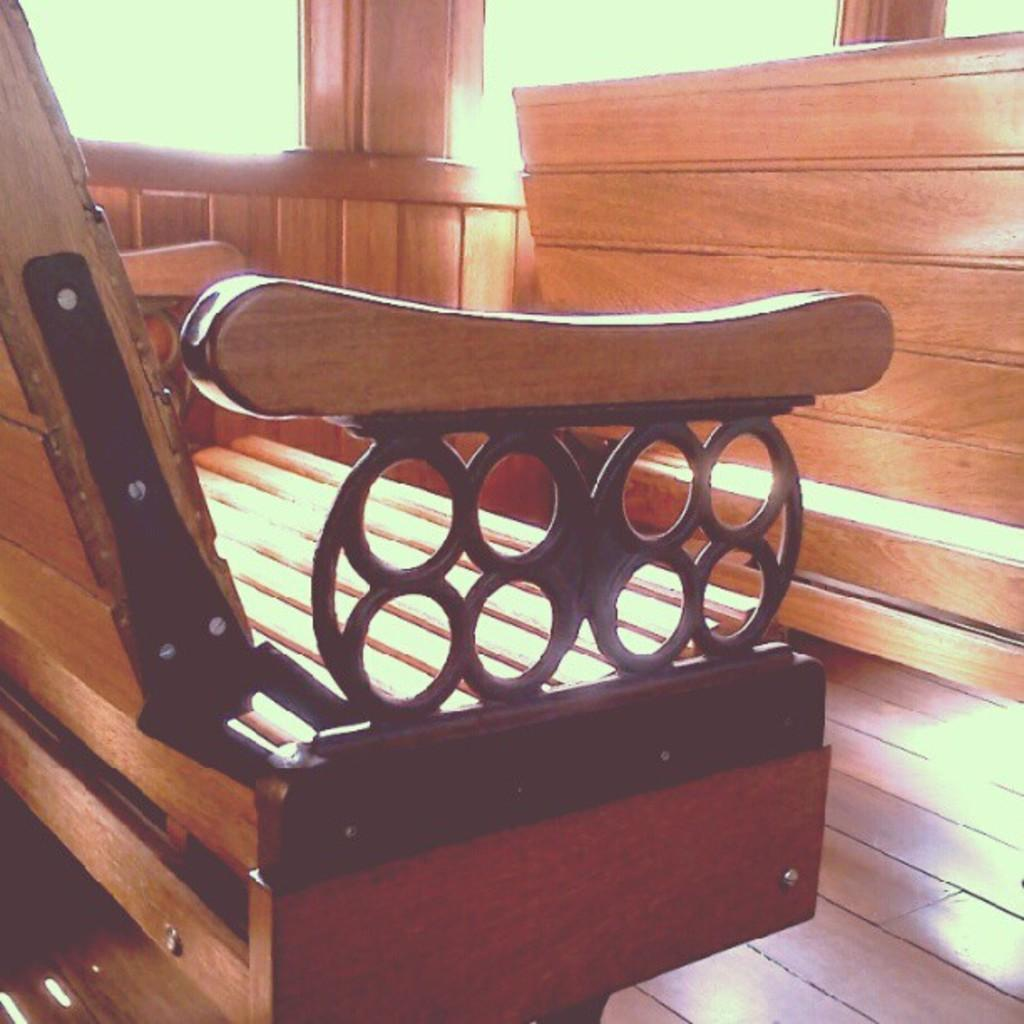What type of seating is present in the image? There are benches in the image. What material are the benches made of? The benches are made of wood. Are there any additional design elements on the benches? Yes, the benches have a metal design. What type of surface is visible in the image? There is a wooden surface in the image. What other objects can be seen in the image? There are poles in the image. How many potatoes are visible on the benches in the image? There are no potatoes present in the image; it features benches made of wood with a metal design and poles. 